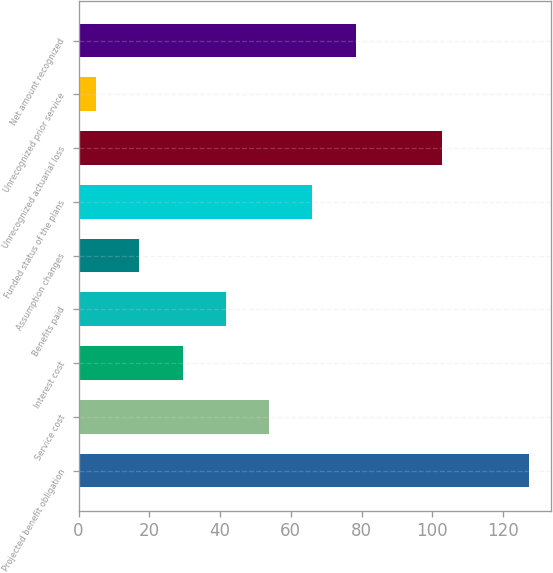<chart> <loc_0><loc_0><loc_500><loc_500><bar_chart><fcel>Projected benefit obligation<fcel>Service cost<fcel>Interest cost<fcel>Benefits paid<fcel>Assumption changes<fcel>Funded status of the plans<fcel>Unrecognized actuarial loss<fcel>Unrecognized prior service<fcel>Net amount recognized<nl><fcel>127.3<fcel>53.86<fcel>29.38<fcel>41.62<fcel>17.14<fcel>66.1<fcel>102.82<fcel>4.9<fcel>78.34<nl></chart> 